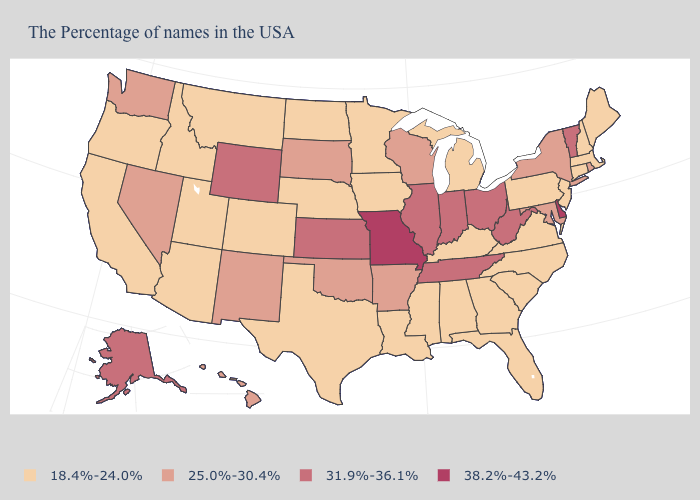What is the value of Arkansas?
Write a very short answer. 25.0%-30.4%. Name the states that have a value in the range 31.9%-36.1%?
Answer briefly. Vermont, West Virginia, Ohio, Indiana, Tennessee, Illinois, Kansas, Wyoming, Alaska. Does Massachusetts have a lower value than Tennessee?
Keep it brief. Yes. Which states have the highest value in the USA?
Write a very short answer. Delaware, Missouri. Among the states that border Utah , which have the highest value?
Quick response, please. Wyoming. What is the value of Indiana?
Quick response, please. 31.9%-36.1%. What is the value of Hawaii?
Write a very short answer. 25.0%-30.4%. Among the states that border Wyoming , does South Dakota have the lowest value?
Give a very brief answer. No. Among the states that border California , which have the lowest value?
Write a very short answer. Arizona, Oregon. Does Oklahoma have the same value as Rhode Island?
Answer briefly. Yes. Name the states that have a value in the range 18.4%-24.0%?
Short answer required. Maine, Massachusetts, New Hampshire, Connecticut, New Jersey, Pennsylvania, Virginia, North Carolina, South Carolina, Florida, Georgia, Michigan, Kentucky, Alabama, Mississippi, Louisiana, Minnesota, Iowa, Nebraska, Texas, North Dakota, Colorado, Utah, Montana, Arizona, Idaho, California, Oregon. Does Tennessee have the lowest value in the South?
Give a very brief answer. No. Name the states that have a value in the range 38.2%-43.2%?
Quick response, please. Delaware, Missouri. Does Vermont have the lowest value in the Northeast?
Answer briefly. No. Does Alabama have a lower value than New Mexico?
Quick response, please. Yes. 